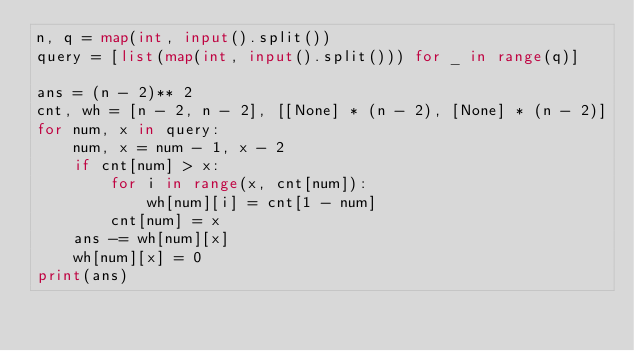Convert code to text. <code><loc_0><loc_0><loc_500><loc_500><_Python_>n, q = map(int, input().split())
query = [list(map(int, input().split())) for _ in range(q)]

ans = (n - 2)** 2
cnt, wh = [n - 2, n - 2], [[None] * (n - 2), [None] * (n - 2)]
for num, x in query:
    num, x = num - 1, x - 2
    if cnt[num] > x:
        for i in range(x, cnt[num]):
            wh[num][i] = cnt[1 - num]
        cnt[num] = x
    ans -= wh[num][x]
    wh[num][x] = 0
print(ans)
</code> 